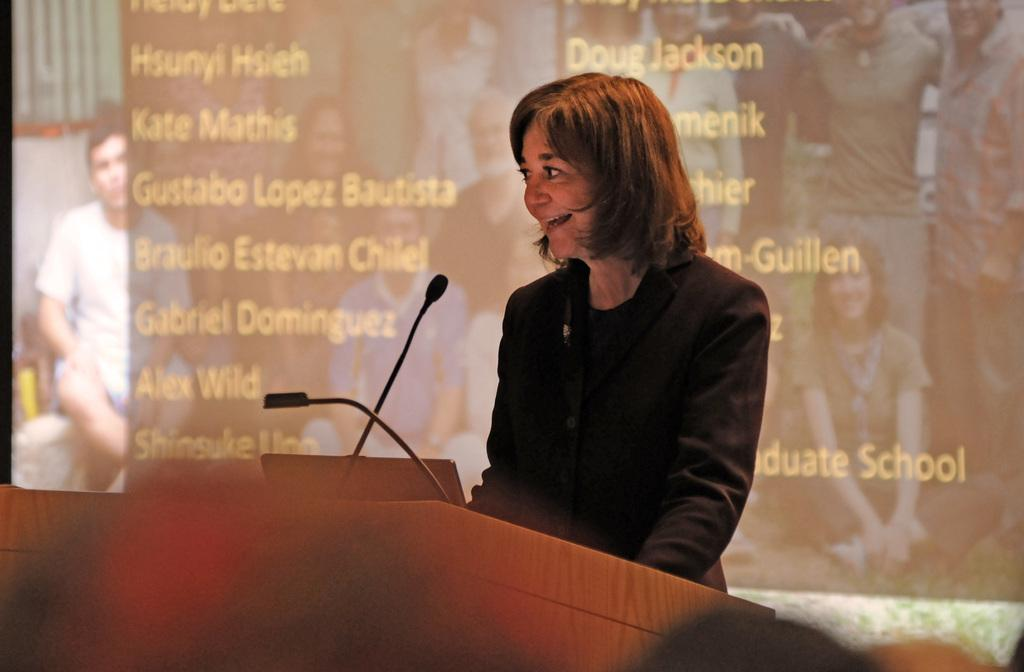What is the person in the image doing? The person is standing in front of a dais. What objects are on top of the dais? There is a laptop and a microphone on top of the dais. What can be seen in the background of the image? There is a screen in the background of the image. Is the person in the image sinking into quicksand? No, there is no quicksand present in the image. The person is standing on a solid surface in front of a dais. 